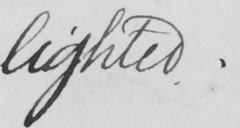Please transcribe the handwritten text in this image. lighted. 